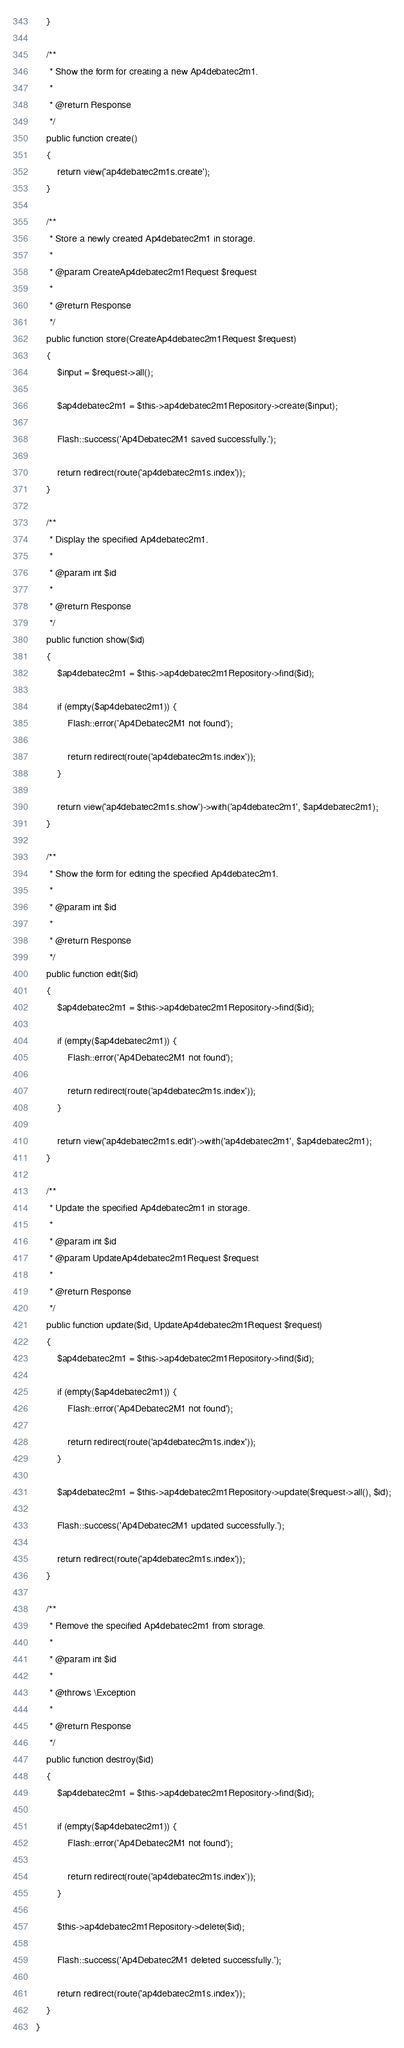Convert code to text. <code><loc_0><loc_0><loc_500><loc_500><_PHP_>    }

    /**
     * Show the form for creating a new Ap4debatec2m1.
     *
     * @return Response
     */
    public function create()
    {
        return view('ap4debatec2m1s.create');
    }

    /**
     * Store a newly created Ap4debatec2m1 in storage.
     *
     * @param CreateAp4debatec2m1Request $request
     *
     * @return Response
     */
    public function store(CreateAp4debatec2m1Request $request)
    {
        $input = $request->all();

        $ap4debatec2m1 = $this->ap4debatec2m1Repository->create($input);

        Flash::success('Ap4Debatec2M1 saved successfully.');

        return redirect(route('ap4debatec2m1s.index'));
    }

    /**
     * Display the specified Ap4debatec2m1.
     *
     * @param int $id
     *
     * @return Response
     */
    public function show($id)
    {
        $ap4debatec2m1 = $this->ap4debatec2m1Repository->find($id);

        if (empty($ap4debatec2m1)) {
            Flash::error('Ap4Debatec2M1 not found');

            return redirect(route('ap4debatec2m1s.index'));
        }

        return view('ap4debatec2m1s.show')->with('ap4debatec2m1', $ap4debatec2m1);
    }

    /**
     * Show the form for editing the specified Ap4debatec2m1.
     *
     * @param int $id
     *
     * @return Response
     */
    public function edit($id)
    {
        $ap4debatec2m1 = $this->ap4debatec2m1Repository->find($id);

        if (empty($ap4debatec2m1)) {
            Flash::error('Ap4Debatec2M1 not found');

            return redirect(route('ap4debatec2m1s.index'));
        }

        return view('ap4debatec2m1s.edit')->with('ap4debatec2m1', $ap4debatec2m1);
    }

    /**
     * Update the specified Ap4debatec2m1 in storage.
     *
     * @param int $id
     * @param UpdateAp4debatec2m1Request $request
     *
     * @return Response
     */
    public function update($id, UpdateAp4debatec2m1Request $request)
    {
        $ap4debatec2m1 = $this->ap4debatec2m1Repository->find($id);

        if (empty($ap4debatec2m1)) {
            Flash::error('Ap4Debatec2M1 not found');

            return redirect(route('ap4debatec2m1s.index'));
        }

        $ap4debatec2m1 = $this->ap4debatec2m1Repository->update($request->all(), $id);

        Flash::success('Ap4Debatec2M1 updated successfully.');

        return redirect(route('ap4debatec2m1s.index'));
    }

    /**
     * Remove the specified Ap4debatec2m1 from storage.
     *
     * @param int $id
     *
     * @throws \Exception
     *
     * @return Response
     */
    public function destroy($id)
    {
        $ap4debatec2m1 = $this->ap4debatec2m1Repository->find($id);

        if (empty($ap4debatec2m1)) {
            Flash::error('Ap4Debatec2M1 not found');

            return redirect(route('ap4debatec2m1s.index'));
        }

        $this->ap4debatec2m1Repository->delete($id);

        Flash::success('Ap4Debatec2M1 deleted successfully.');

        return redirect(route('ap4debatec2m1s.index'));
    }
}
</code> 